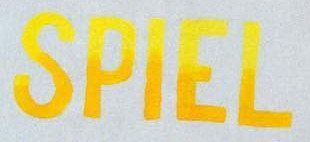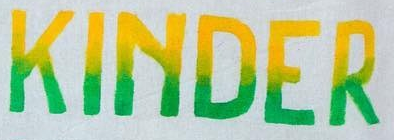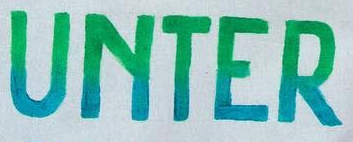What words can you see in these images in sequence, separated by a semicolon? SPIEL; KINDER; UNTER 